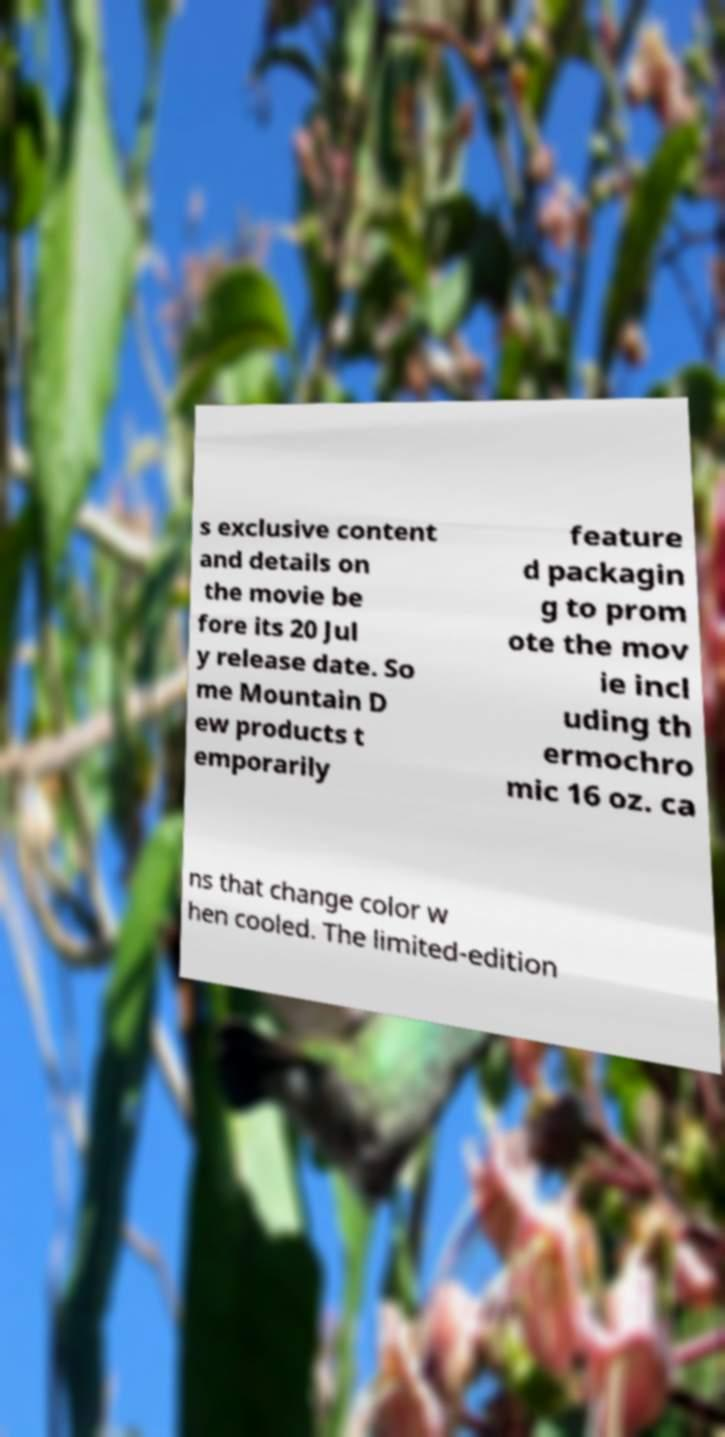Could you extract and type out the text from this image? s exclusive content and details on the movie be fore its 20 Jul y release date. So me Mountain D ew products t emporarily feature d packagin g to prom ote the mov ie incl uding th ermochro mic 16 oz. ca ns that change color w hen cooled. The limited-edition 